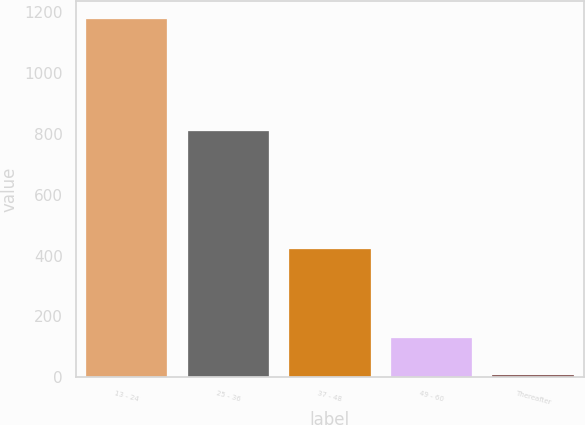<chart> <loc_0><loc_0><loc_500><loc_500><bar_chart><fcel>13 - 24<fcel>25 - 36<fcel>37 - 48<fcel>49 - 60<fcel>Thereafter<nl><fcel>1177<fcel>808<fcel>422<fcel>130<fcel>9<nl></chart> 